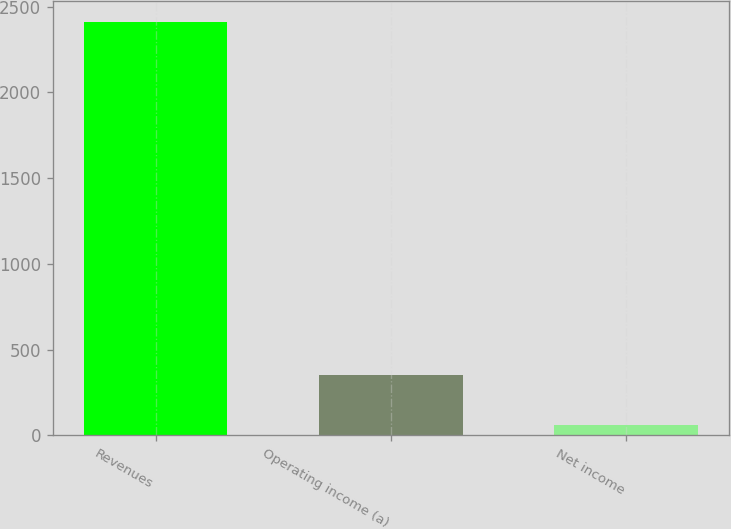Convert chart. <chart><loc_0><loc_0><loc_500><loc_500><bar_chart><fcel>Revenues<fcel>Operating income (a)<fcel>Net income<nl><fcel>2411<fcel>353<fcel>59<nl></chart> 